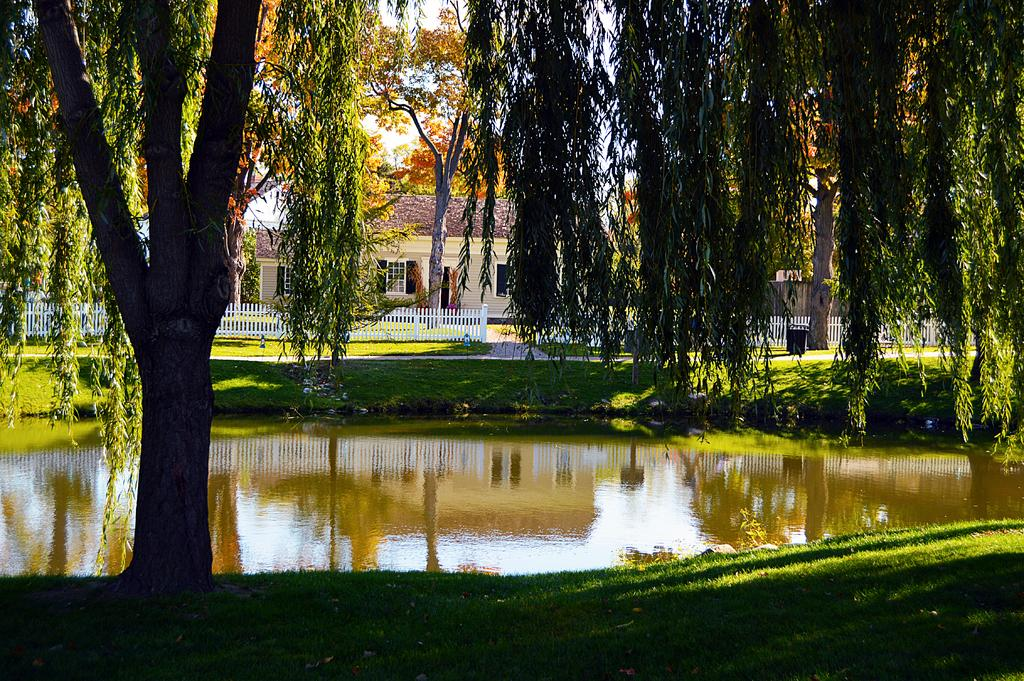What type of vegetation is present in the image? There is grass in the image. What natural element is also present in the image? There is water in the image. What type of barrier can be seen in the image? There is a fence in the image. What type of structure is visible in the image? There is a building in the image. What other type of vegetation is present in the image? There are trees in the image. What else can be seen in the image besides the vegetation and structure? There are some objects in the image. What can be seen in the background of the image? The sky is visible in the background of the image. How many eyes can be seen on the cat in the image? There is no cat present in the image, so the number of eyes cannot be determined. What type of metal is used to make the zinc fence in the image? There is no zinc fence present in the image; the fence is not mentioned to be made of zinc. 